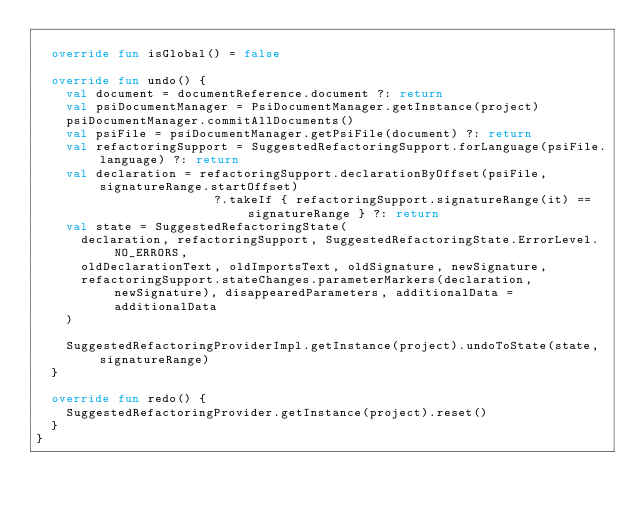<code> <loc_0><loc_0><loc_500><loc_500><_Kotlin_>
  override fun isGlobal() = false

  override fun undo() {
    val document = documentReference.document ?: return
    val psiDocumentManager = PsiDocumentManager.getInstance(project)
    psiDocumentManager.commitAllDocuments()
    val psiFile = psiDocumentManager.getPsiFile(document) ?: return
    val refactoringSupport = SuggestedRefactoringSupport.forLanguage(psiFile.language) ?: return
    val declaration = refactoringSupport.declarationByOffset(psiFile, signatureRange.startOffset)
                        ?.takeIf { refactoringSupport.signatureRange(it) == signatureRange } ?: return
    val state = SuggestedRefactoringState(
      declaration, refactoringSupport, SuggestedRefactoringState.ErrorLevel.NO_ERRORS,
      oldDeclarationText, oldImportsText, oldSignature, newSignature,
      refactoringSupport.stateChanges.parameterMarkers(declaration, newSignature), disappearedParameters, additionalData = additionalData
    )

    SuggestedRefactoringProviderImpl.getInstance(project).undoToState(state, signatureRange)
  }

  override fun redo() {
    SuggestedRefactoringProvider.getInstance(project).reset()
  }
}</code> 